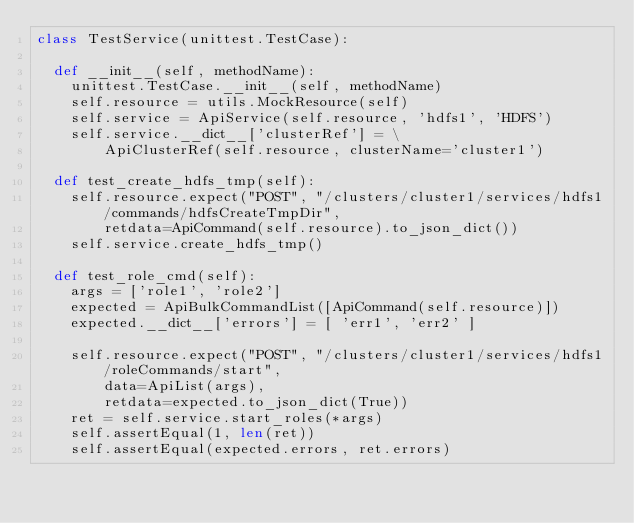Convert code to text. <code><loc_0><loc_0><loc_500><loc_500><_Python_>class TestService(unittest.TestCase):

  def __init__(self, methodName):
    unittest.TestCase.__init__(self, methodName)
    self.resource = utils.MockResource(self)
    self.service = ApiService(self.resource, 'hdfs1', 'HDFS')
    self.service.__dict__['clusterRef'] = \
        ApiClusterRef(self.resource, clusterName='cluster1')

  def test_create_hdfs_tmp(self):
    self.resource.expect("POST", "/clusters/cluster1/services/hdfs1/commands/hdfsCreateTmpDir",
        retdata=ApiCommand(self.resource).to_json_dict())
    self.service.create_hdfs_tmp()

  def test_role_cmd(self):
    args = ['role1', 'role2']
    expected = ApiBulkCommandList([ApiCommand(self.resource)])
    expected.__dict__['errors'] = [ 'err1', 'err2' ]

    self.resource.expect("POST", "/clusters/cluster1/services/hdfs1/roleCommands/start",
        data=ApiList(args),
        retdata=expected.to_json_dict(True))
    ret = self.service.start_roles(*args)
    self.assertEqual(1, len(ret))
    self.assertEqual(expected.errors, ret.errors)
</code> 